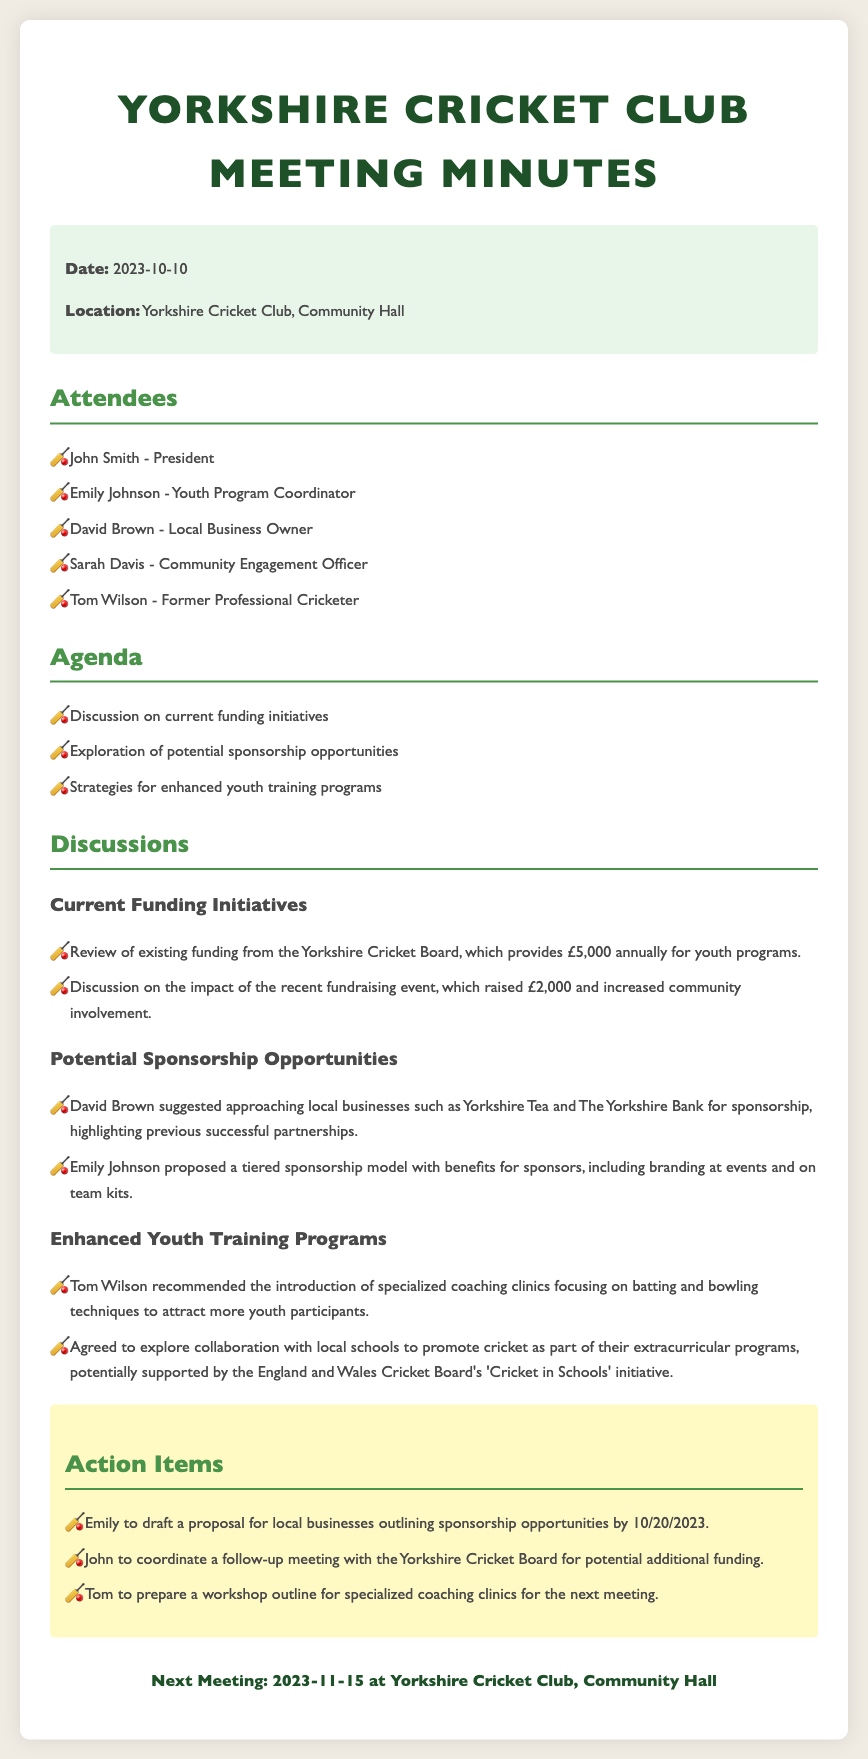What is the date of the meeting? The date of the meeting is provided in the document's info section.
Answer: 2023-10-10 Who proposed a tiered sponsorship model? This information can be found under the potential sponsorship opportunities section indicating who made the proposal.
Answer: Emily Johnson How much funding does the Yorkshire Cricket Board provide annually? The annual funding amount from the Yorkshire Cricket Board is explicitly stated in the discussions about current funding initiatives.
Answer: £5,000 What amount was raised from the recent fundraising event? The amount raised during the fundraising event is mentioned in the section discussing current funding initiatives.
Answer: £2,000 Which local business was suggested by David Brown for sponsorship? David Brown's suggestion of a local business for sponsorship can be found under the potential sponsorship opportunities section.
Answer: Yorkshire Tea What is the next meeting date? The next meeting date is listed at the bottom of the document.
Answer: 2023-11-15 Who is responsible for drafting the sponsorship proposal? The action items specify who will take responsibility for drafting the proposal for local businesses.
Answer: Emily What aspect of cricket training did Tom Wilson recommend? Tom Wilson's recommendation is detailed in the enhanced youth training programs section.
Answer: Specialized coaching clinics Why is collaboration with local schools being explored? The reasoning for exploring collaboration with local schools relates to promoting cricket as mentioned in the document.
Answer: To promote cricket as part of extracurricular programs 